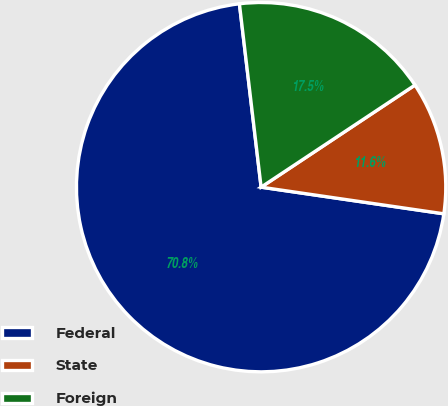Convert chart to OTSL. <chart><loc_0><loc_0><loc_500><loc_500><pie_chart><fcel>Federal<fcel>State<fcel>Foreign<nl><fcel>70.82%<fcel>11.63%<fcel>17.55%<nl></chart> 